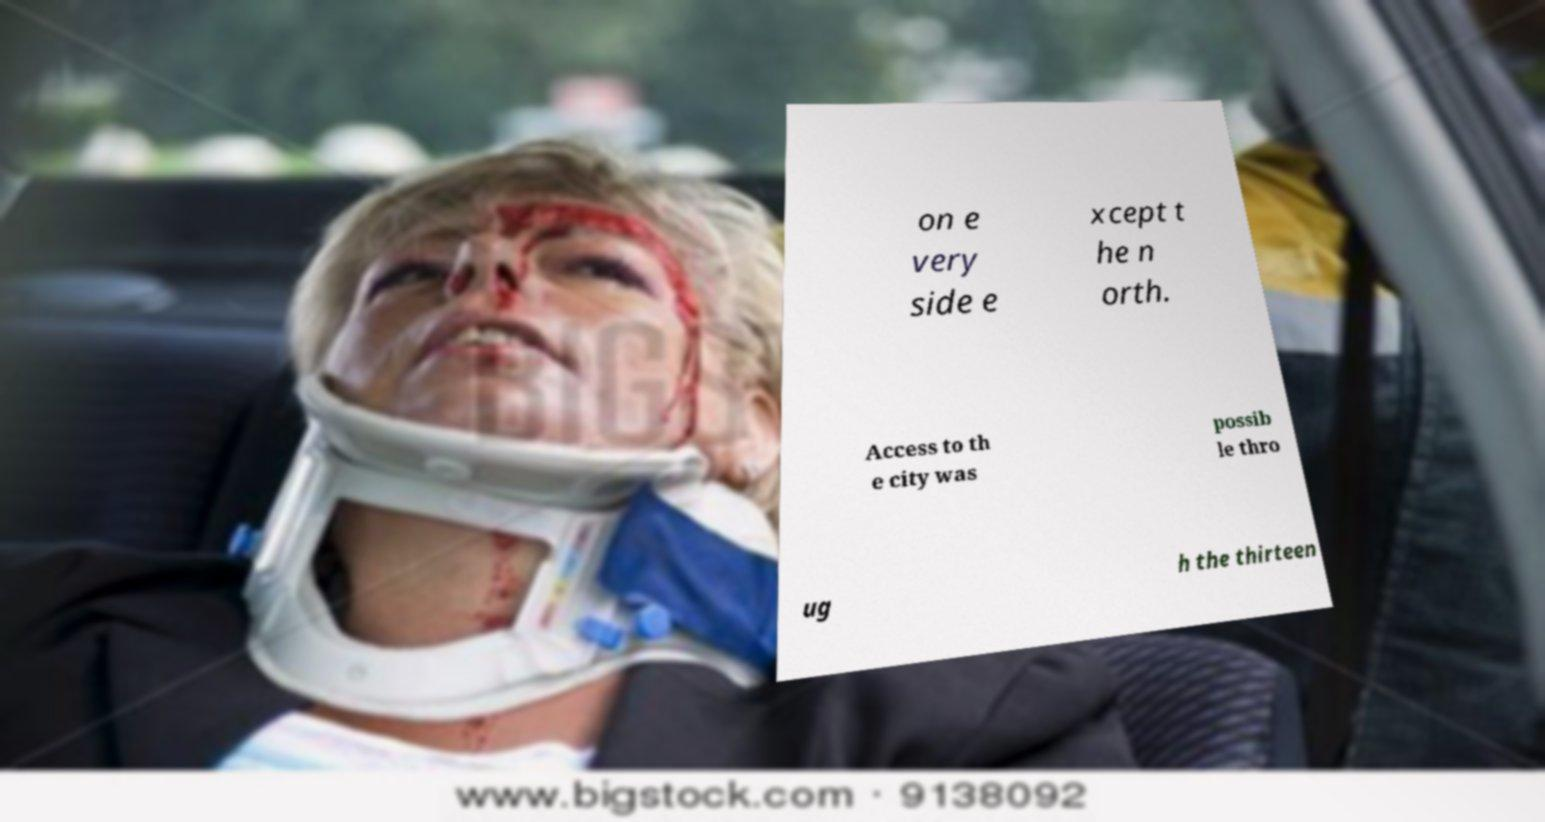I need the written content from this picture converted into text. Can you do that? on e very side e xcept t he n orth. Access to th e city was possib le thro ug h the thirteen 